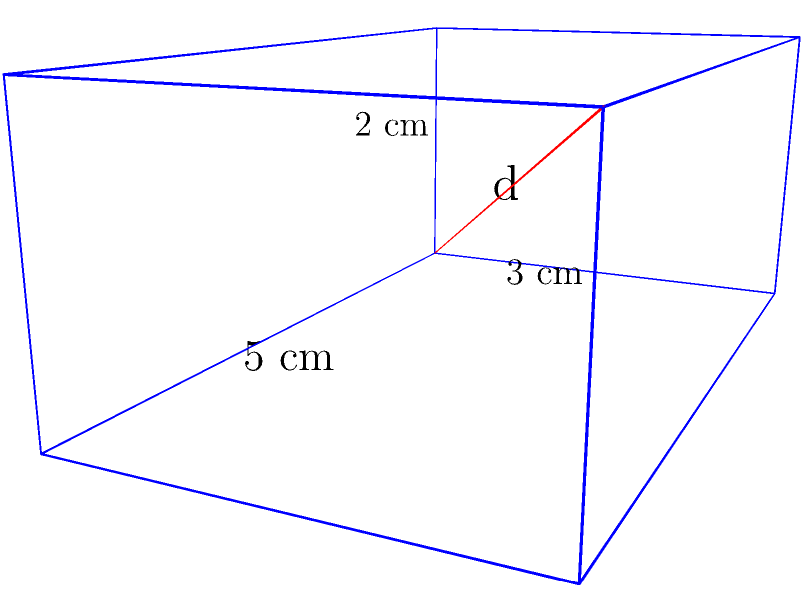In the Museum of Colombian History, a rectangular display case is being designed to showcase a rare pre-Columbian artifact. The case measures 5 cm in length, 3 cm in width, and 2 cm in height. What is the length of the diagonal (d) of this display case, rounded to two decimal places? To find the diagonal length of a rectangular prism, we can use the three-dimensional extension of the Pythagorean theorem:

$$d^2 = l^2 + w^2 + h^2$$

Where:
$d$ is the diagonal length
$l$ is the length (5 cm)
$w$ is the width (3 cm)
$h$ is the height (2 cm)

Let's substitute these values:

$$d^2 = 5^2 + 3^2 + 2^2$$

Now, let's calculate:

$$d^2 = 25 + 9 + 4 = 38$$

To find $d$, we take the square root of both sides:

$$d = \sqrt{38}$$

Using a calculator and rounding to two decimal places:

$$d \approx 6.16 \text{ cm}$$

This diagonal represents the longest straight line that can be drawn within the display case, from one corner to the opposite corner diagonally across the case.
Answer: 6.16 cm 